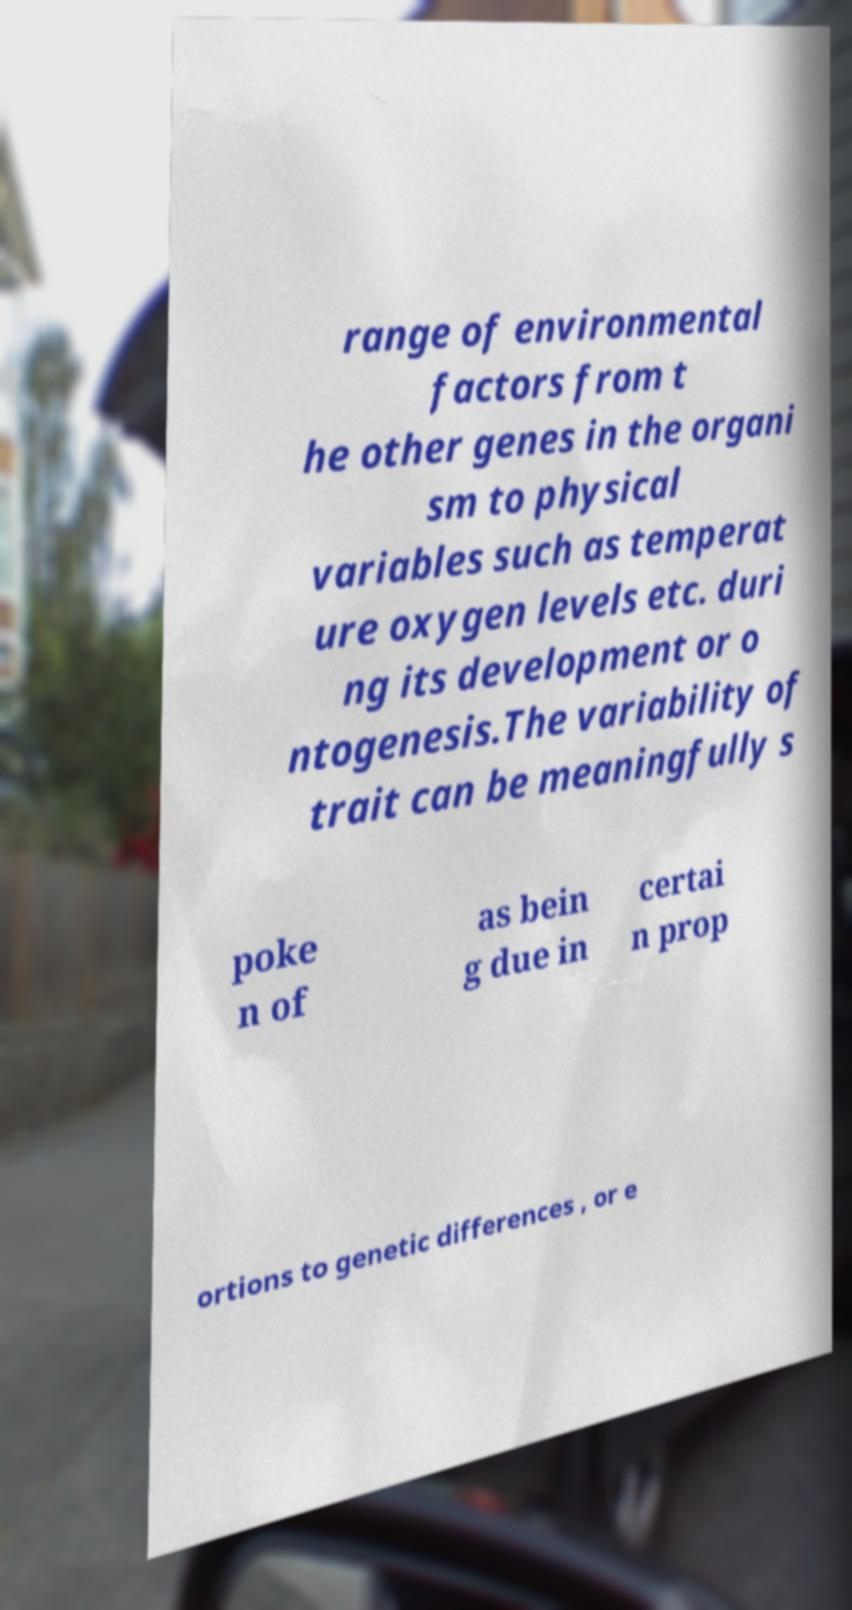What messages or text are displayed in this image? I need them in a readable, typed format. range of environmental factors from t he other genes in the organi sm to physical variables such as temperat ure oxygen levels etc. duri ng its development or o ntogenesis.The variability of trait can be meaningfully s poke n of as bein g due in certai n prop ortions to genetic differences , or e 